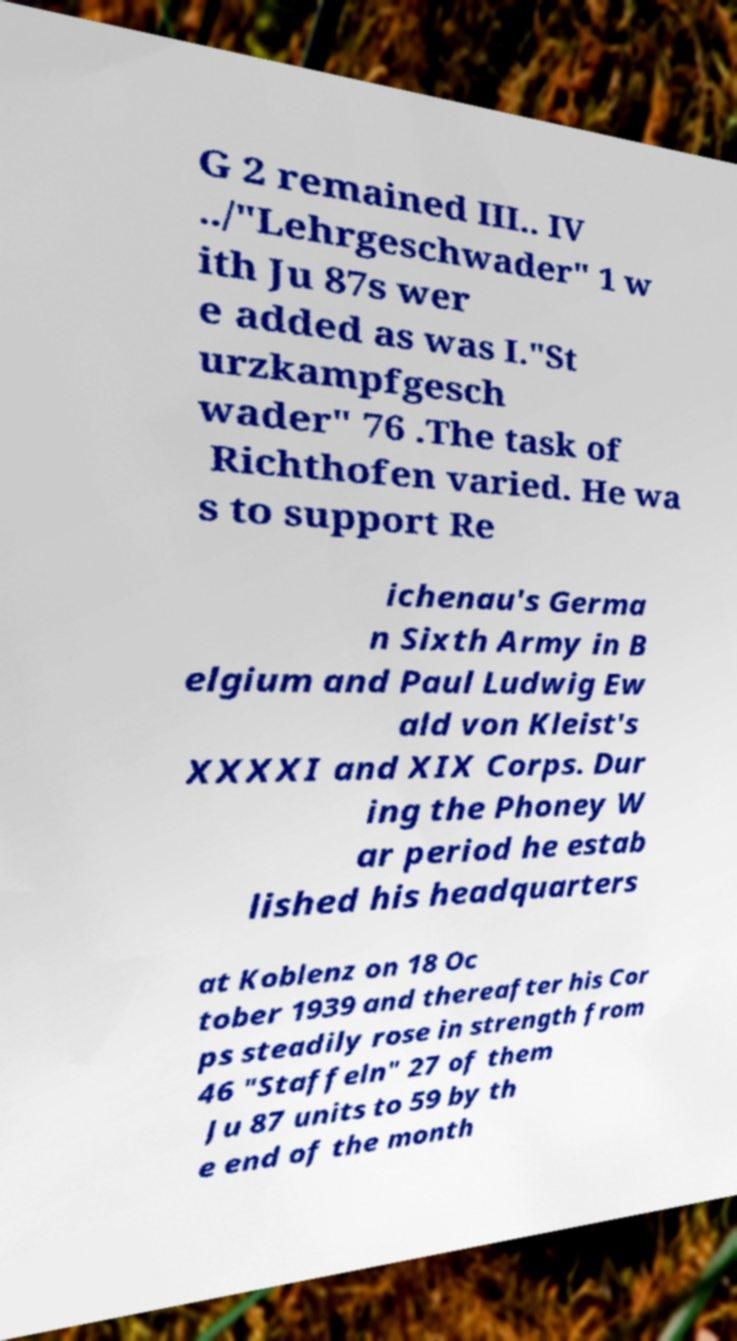For documentation purposes, I need the text within this image transcribed. Could you provide that? G 2 remained III.. IV ../"Lehrgeschwader" 1 w ith Ju 87s wer e added as was I."St urzkampfgesch wader" 76 .The task of Richthofen varied. He wa s to support Re ichenau's Germa n Sixth Army in B elgium and Paul Ludwig Ew ald von Kleist's XXXXI and XIX Corps. Dur ing the Phoney W ar period he estab lished his headquarters at Koblenz on 18 Oc tober 1939 and thereafter his Cor ps steadily rose in strength from 46 "Staffeln" 27 of them Ju 87 units to 59 by th e end of the month 